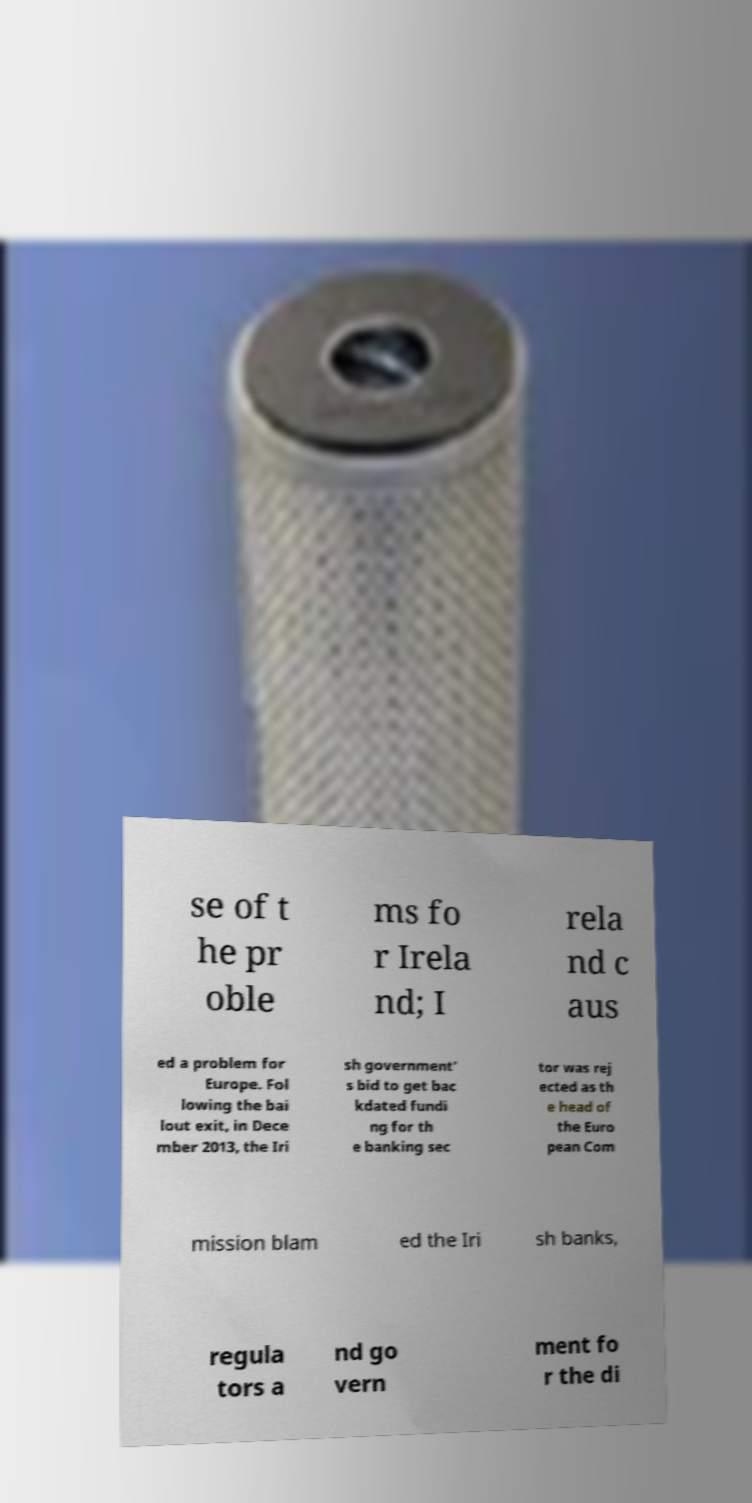There's text embedded in this image that I need extracted. Can you transcribe it verbatim? se of t he pr oble ms fo r Irela nd; I rela nd c aus ed a problem for Europe. Fol lowing the bai lout exit, in Dece mber 2013, the Iri sh government' s bid to get bac kdated fundi ng for th e banking sec tor was rej ected as th e head of the Euro pean Com mission blam ed the Iri sh banks, regula tors a nd go vern ment fo r the di 